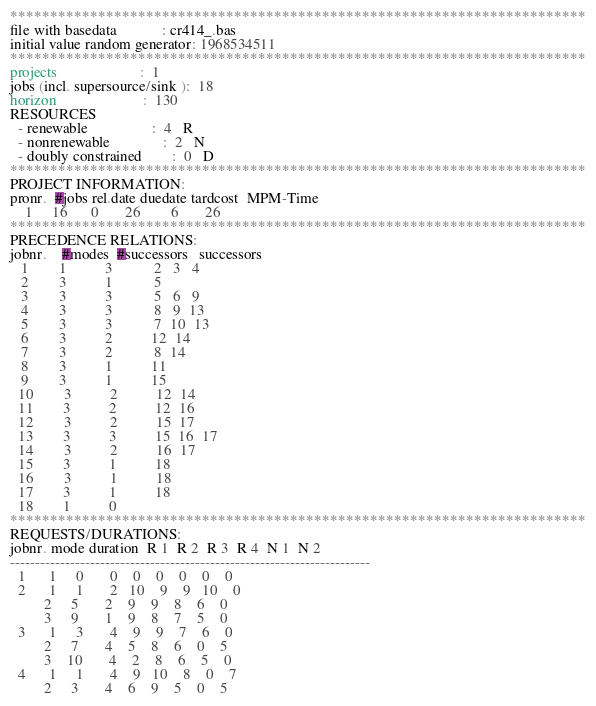<code> <loc_0><loc_0><loc_500><loc_500><_ObjectiveC_>************************************************************************
file with basedata            : cr414_.bas
initial value random generator: 1968534511
************************************************************************
projects                      :  1
jobs (incl. supersource/sink ):  18
horizon                       :  130
RESOURCES
  - renewable                 :  4   R
  - nonrenewable              :  2   N
  - doubly constrained        :  0   D
************************************************************************
PROJECT INFORMATION:
pronr.  #jobs rel.date duedate tardcost  MPM-Time
    1     16      0       26        6       26
************************************************************************
PRECEDENCE RELATIONS:
jobnr.    #modes  #successors   successors
   1        1          3           2   3   4
   2        3          1           5
   3        3          3           5   6   9
   4        3          3           8   9  13
   5        3          3           7  10  13
   6        3          2          12  14
   7        3          2           8  14
   8        3          1          11
   9        3          1          15
  10        3          2          12  14
  11        3          2          12  16
  12        3          2          15  17
  13        3          3          15  16  17
  14        3          2          16  17
  15        3          1          18
  16        3          1          18
  17        3          1          18
  18        1          0        
************************************************************************
REQUESTS/DURATIONS:
jobnr. mode duration  R 1  R 2  R 3  R 4  N 1  N 2
------------------------------------------------------------------------
  1      1     0       0    0    0    0    0    0
  2      1     1       2   10    9    9   10    0
         2     5       2    9    9    8    6    0
         3     9       1    9    8    7    5    0
  3      1     3       4    9    9    7    6    0
         2     7       4    5    8    6    0    5
         3    10       4    2    8    6    5    0
  4      1     1       4    9   10    8    0    7
         2     3       4    6    9    5    0    5</code> 